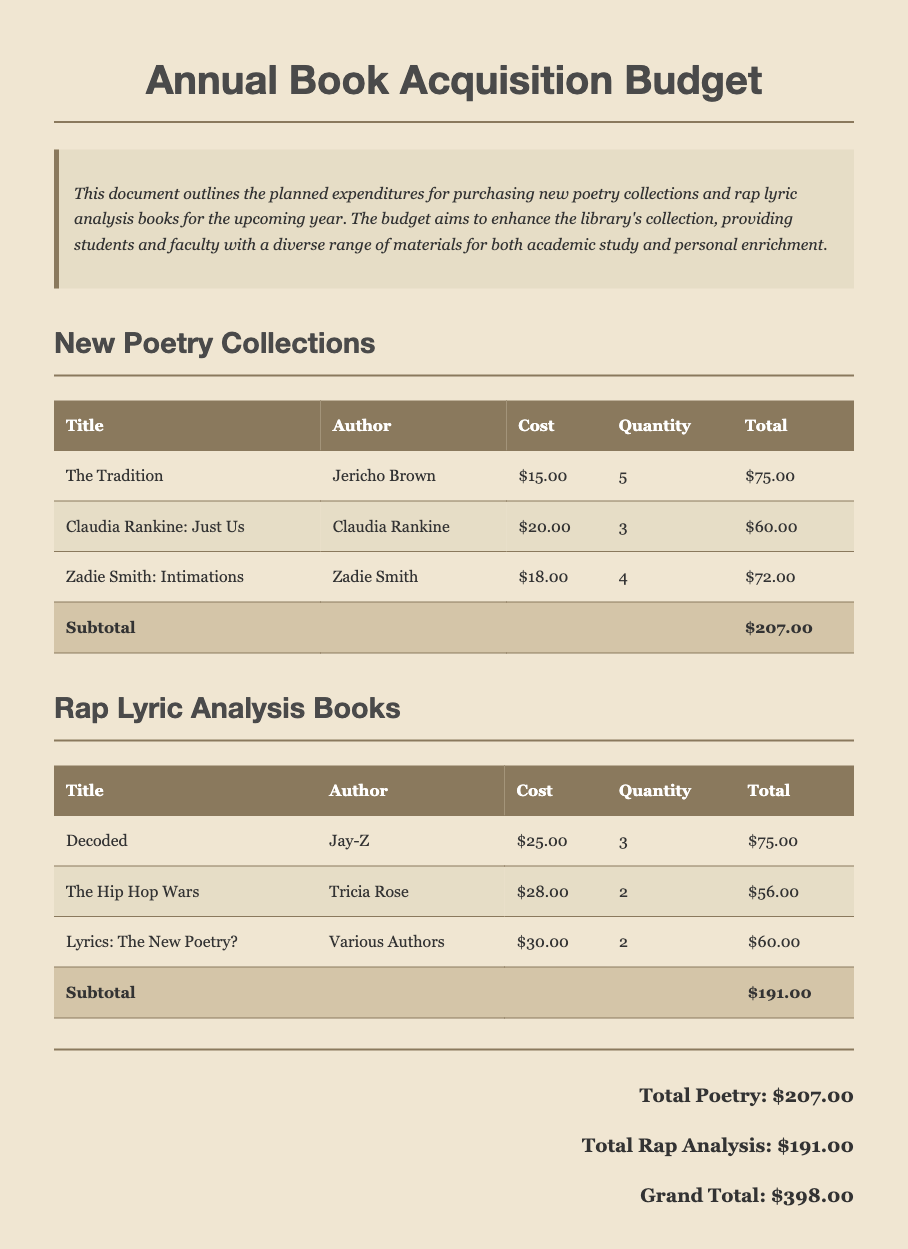What is the total budget for poetry collections? The total budget for poetry collections is specified in the document under the total section, which is $207.00.
Answer: $207.00 Who is the author of "Decoded"? The document lists Jay-Z as the author of "Decoded" in the rap lyric analysis books section.
Answer: Jay-Z How many copies of "Claudia Rankine: Just Us" are planned for purchase? The document indicates that 3 copies of "Claudia Rankine: Just Us" are planned for purchase.
Answer: 3 What is the grand total amount for the entire budget? The grand total can be found at the end of the document, summing all expenditures, which is $398.00.
Answer: $398.00 Which book has the highest cost listed in the rap lyric analysis books section? If we examine the costs in the table, "Lyrics: The New Poetry?" is priced at $30.00, indicating it is the highest.
Answer: Lyrics: The New Poetry? What category has the lower subtotal, poetry collections or rap analysis books? By comparing the subtotals in the document, poetry collections total $207.00 and rap lyric analysis books total $191.00.
Answer: Rap lyric analysis books How many total volumes are being acquired for "The Tradition"? The document specifies a quantity of 5 volumes for "The Tradition" in the poetry collections section.
Answer: 5 What is the subtotal for the rap lyric analysis books? The subtotal for the rap lyric analysis books is clearly stated in the table as $191.00.
Answer: $191.00 